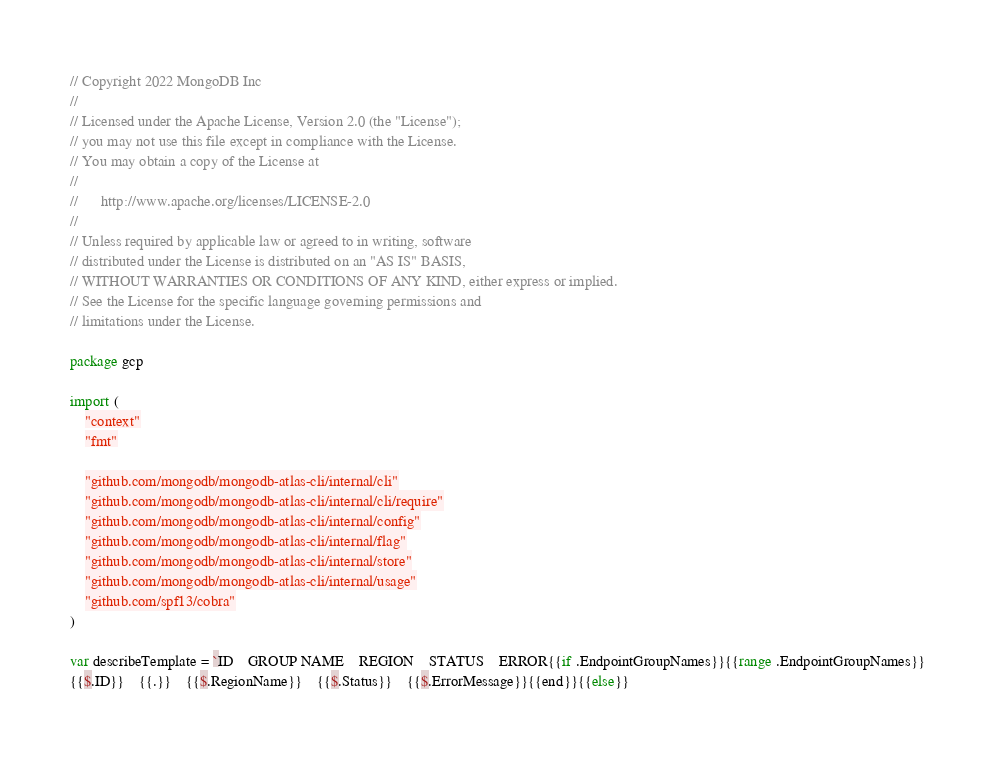Convert code to text. <code><loc_0><loc_0><loc_500><loc_500><_Go_>// Copyright 2022 MongoDB Inc
//
// Licensed under the Apache License, Version 2.0 (the "License");
// you may not use this file except in compliance with the License.
// You may obtain a copy of the License at
//
//      http://www.apache.org/licenses/LICENSE-2.0
//
// Unless required by applicable law or agreed to in writing, software
// distributed under the License is distributed on an "AS IS" BASIS,
// WITHOUT WARRANTIES OR CONDITIONS OF ANY KIND, either express or implied.
// See the License for the specific language governing permissions and
// limitations under the License.

package gcp

import (
	"context"
	"fmt"

	"github.com/mongodb/mongodb-atlas-cli/internal/cli"
	"github.com/mongodb/mongodb-atlas-cli/internal/cli/require"
	"github.com/mongodb/mongodb-atlas-cli/internal/config"
	"github.com/mongodb/mongodb-atlas-cli/internal/flag"
	"github.com/mongodb/mongodb-atlas-cli/internal/store"
	"github.com/mongodb/mongodb-atlas-cli/internal/usage"
	"github.com/spf13/cobra"
)

var describeTemplate = `ID	GROUP NAME	REGION	STATUS	ERROR{{if .EndpointGroupNames}}{{range .EndpointGroupNames}}
{{$.ID}}	{{.}}	{{$.RegionName}}	{{$.Status}}	{{$.ErrorMessage}}{{end}}{{else}}</code> 